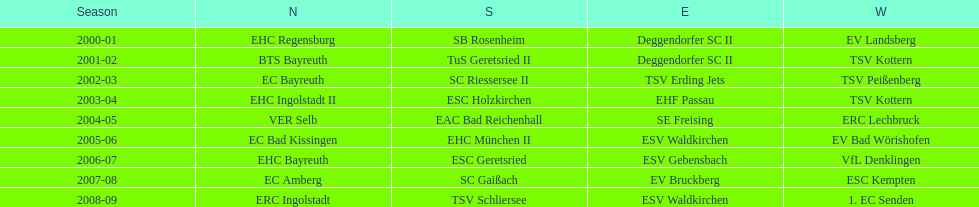The last team to win the west? 1. EC Senden. 